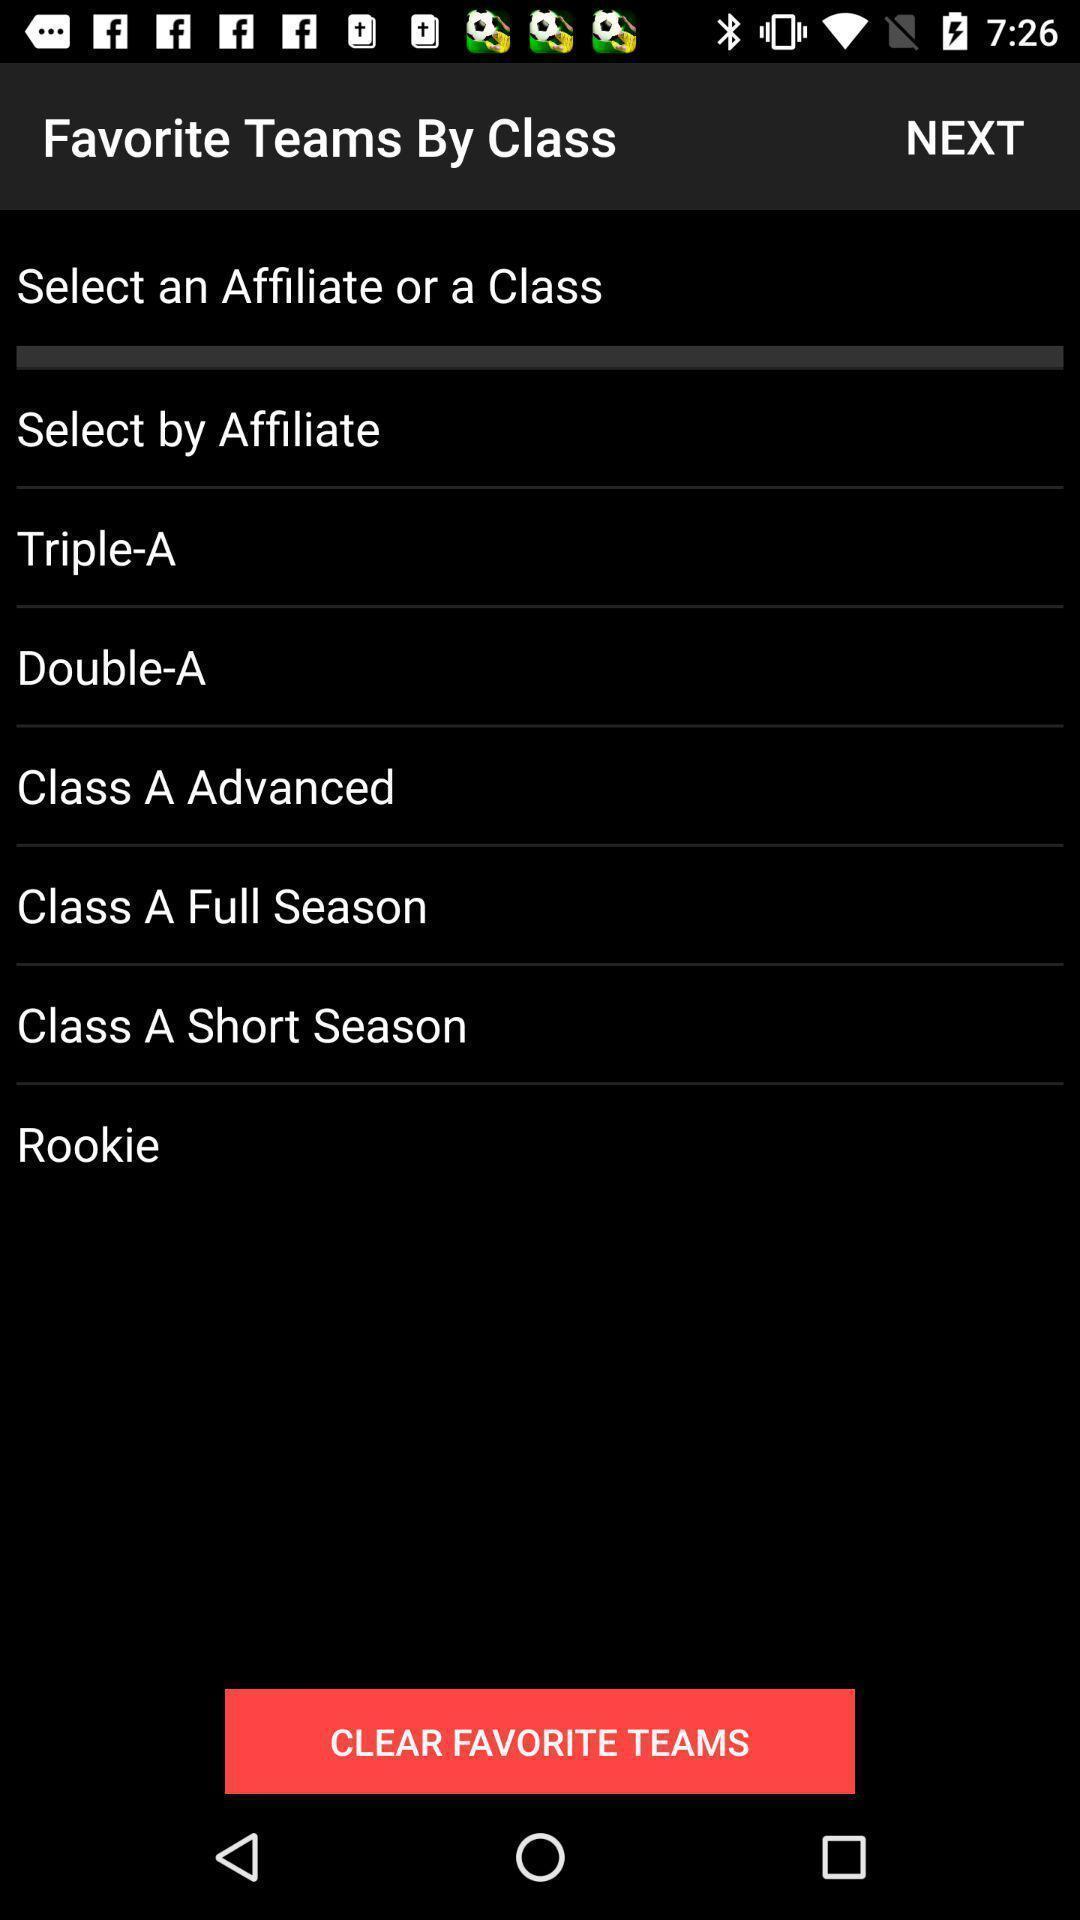Describe the content in this image. Screen shows favorite teams by class. 